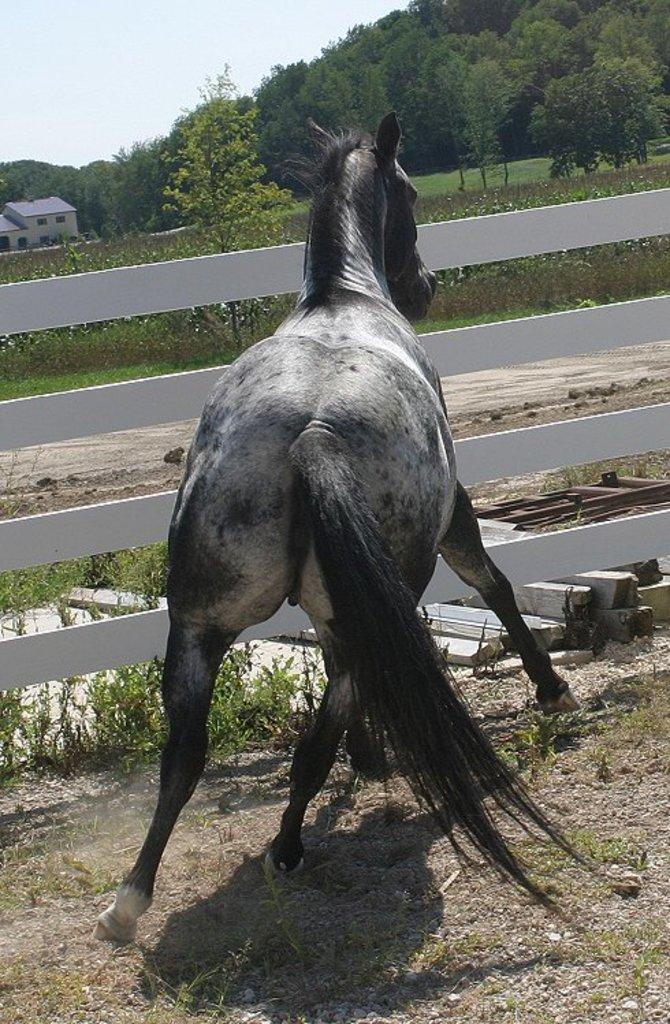Please provide a concise description of this image. In this image I can see a horse on the ground. In the background there are many trees and a house. In front of the horse there are some wooden sticks placed on the ground. At the top of the image I can see the sky. 